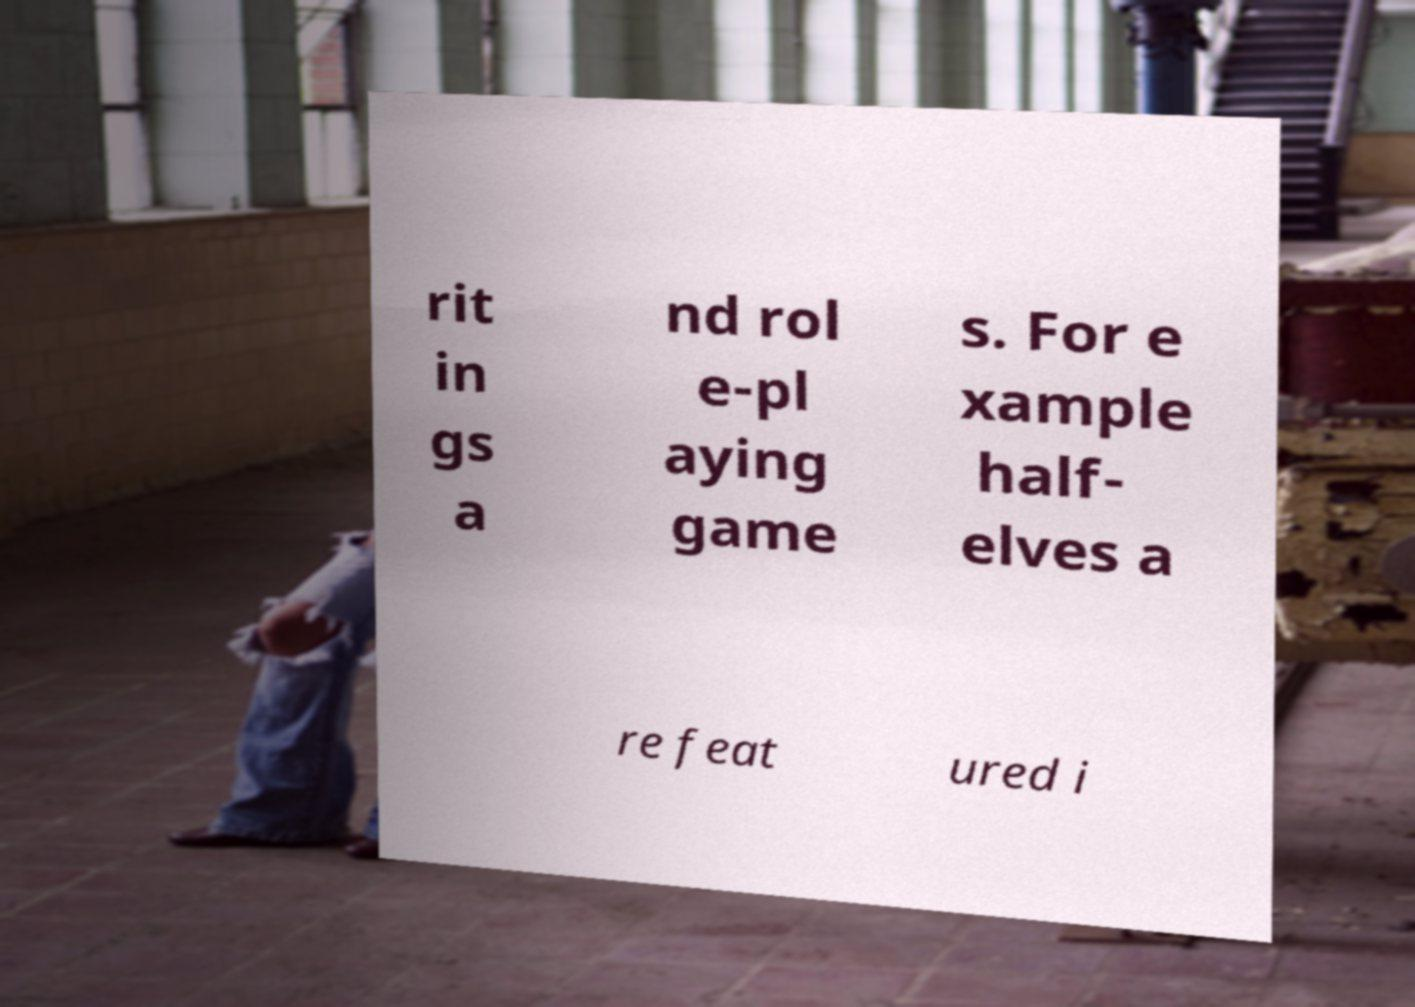I need the written content from this picture converted into text. Can you do that? rit in gs a nd rol e-pl aying game s. For e xample half- elves a re feat ured i 